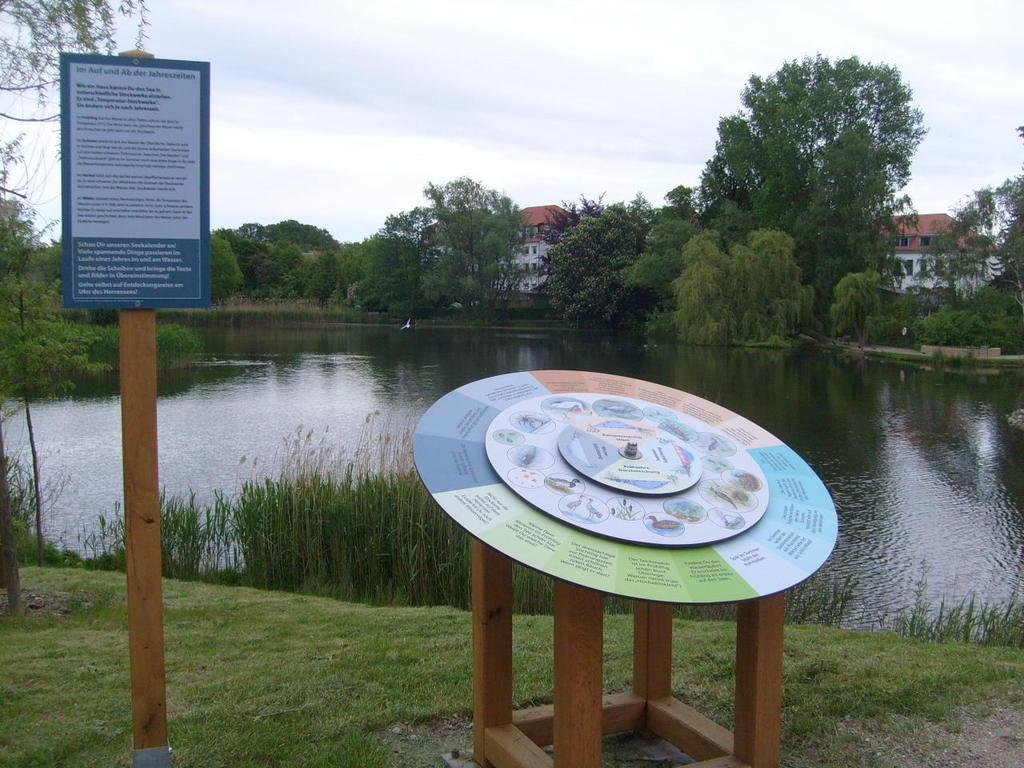What type of vegetation can be seen in the image? There are trees, plants, and grass visible in the image. What type of structure is present in the image? There is a house in the image. What natural element is visible in the image? Water is visible in the image. What is the surface material in the image? There is grass in the image. What object can be seen in the image that is not a part of the natural environment? There is a board in the image. What is visible in the sky in the image? The sky is visible in the image, and there are clouds present. How many clocks are visible in the image? There are no clocks present in the image. What type of vegetable is growing in the image? There are no vegetables visible in the image; it features trees, plants, and grass. 